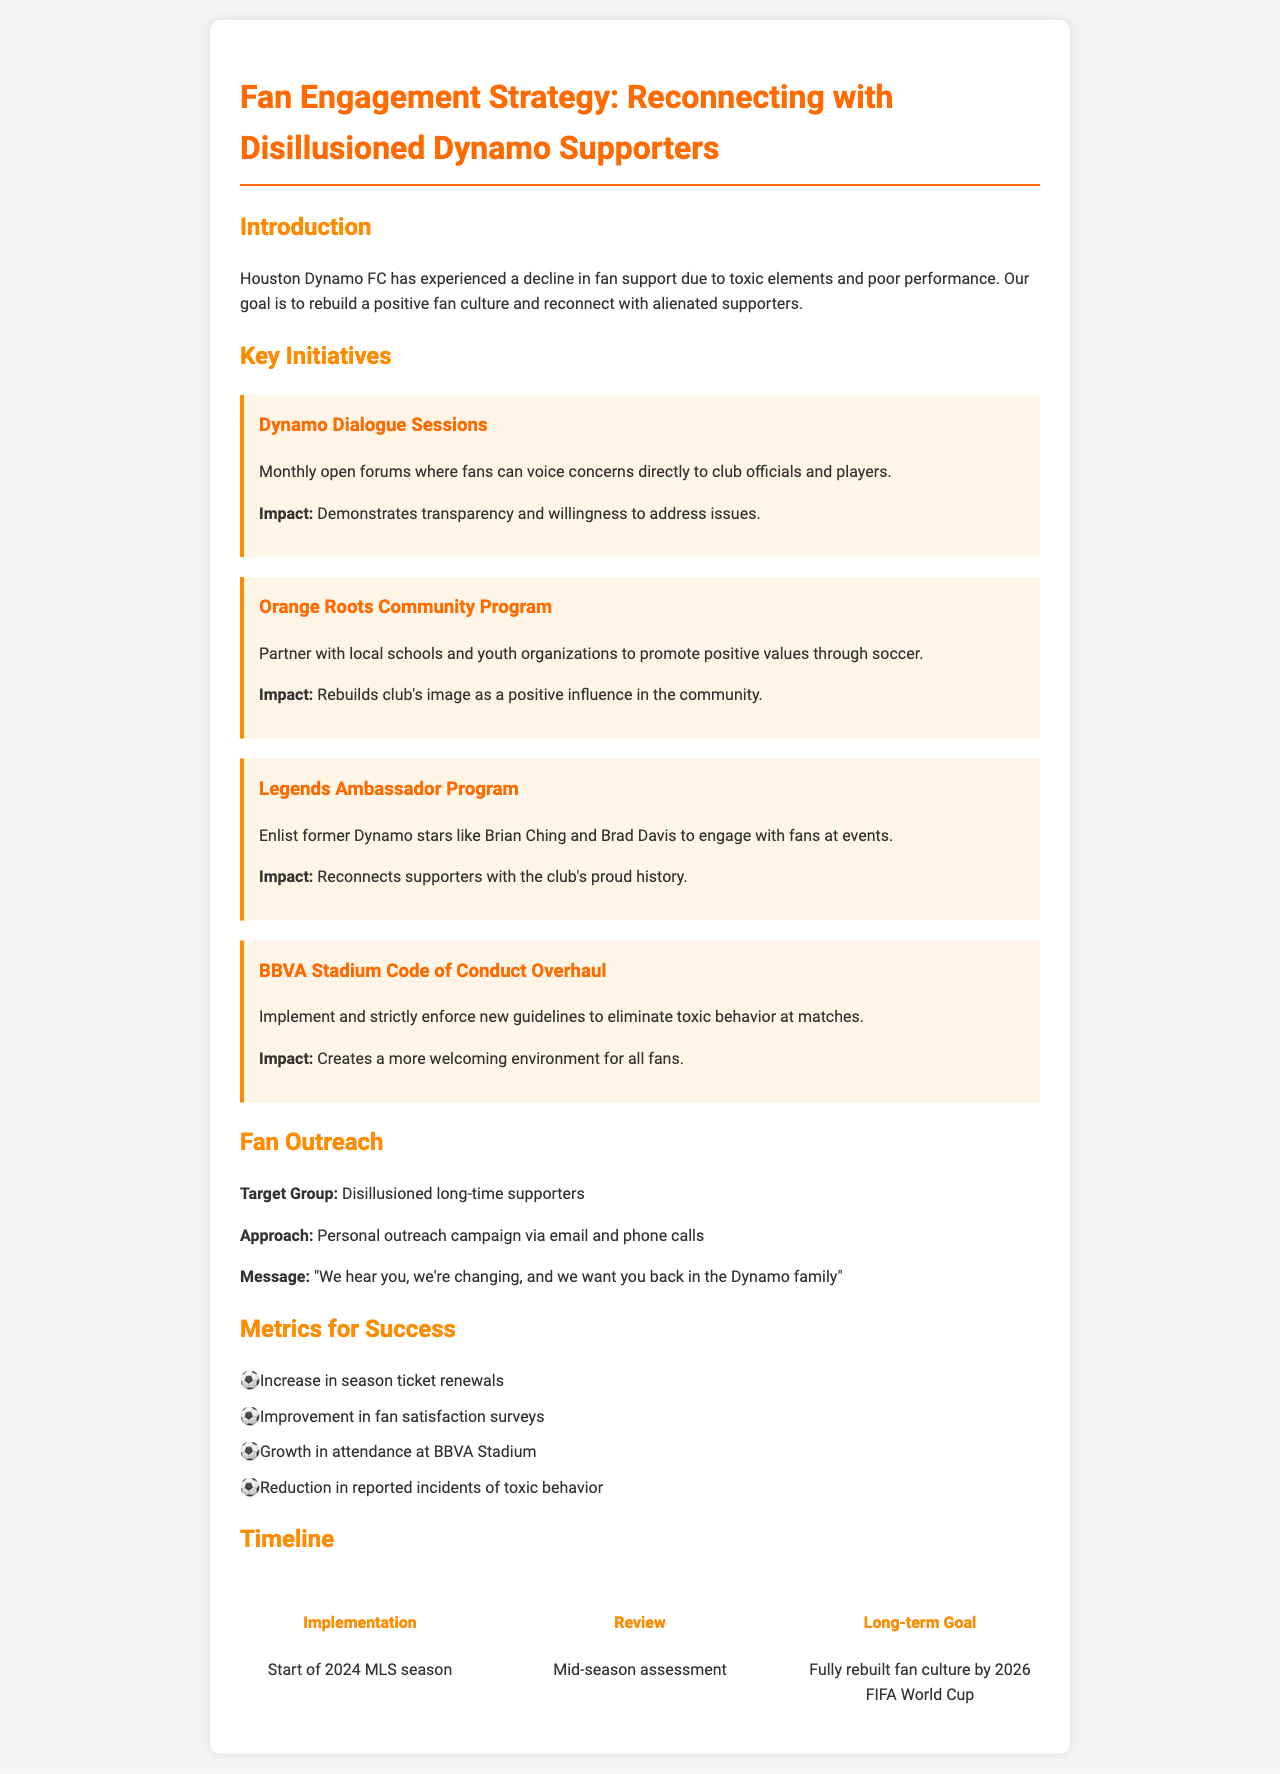What is the title of the document? The title of the document is the heading displayed at the top of the rendered page.
Answer: Fan Engagement Strategy: Reconnecting with Disillusioned Dynamo Supporters What are the main goals of the Fan Engagement Strategy? The primary goals are stated in the introduction, which talks about rebuilding a positive fan culture and reconnecting with supporters.
Answer: Rebuild a positive fan culture and reconnect with alienated supporters When will the implementation of the initiatives begin? The timeline specifies the start of implementations as indicated in the first timeline item.
Answer: Start of 2024 MLS season What is one of the initiatives aimed at improving fan culture? Each initiative section presents a specific action designed to engage fans, and one initiative is highlighted for transparency.
Answer: Dynamo Dialogue Sessions Who is involved in the Legends Ambassador Program? This program specifically enlists former Dynamo stars to engage with fans, as stated under the respective initiative.
Answer: Brian Ching and Brad Davis What is the target group for fan outreach? The document details the specific demographic that the outreach is aimed at, directly mentioned in the outreach section.
Answer: Disillusioned long-time supporters What is a metric for measuring success? This section lists various metrics that will be used to evaluate the impact of the strategy.
Answer: Increase in season ticket renewals What is the long-term goal mentioned in the timeline? The document specifies a long-term aspirational goal to be achieved by a certain event.
Answer: Fully rebuilt fan culture by 2026 FIFA World Cup 